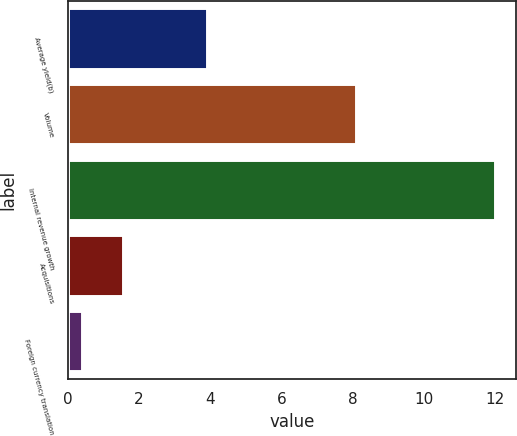<chart> <loc_0><loc_0><loc_500><loc_500><bar_chart><fcel>Average yield(b)<fcel>Volume<fcel>Internal revenue growth<fcel>Acquisitions<fcel>Foreign currency translation<nl><fcel>3.9<fcel>8.1<fcel>12<fcel>1.56<fcel>0.4<nl></chart> 